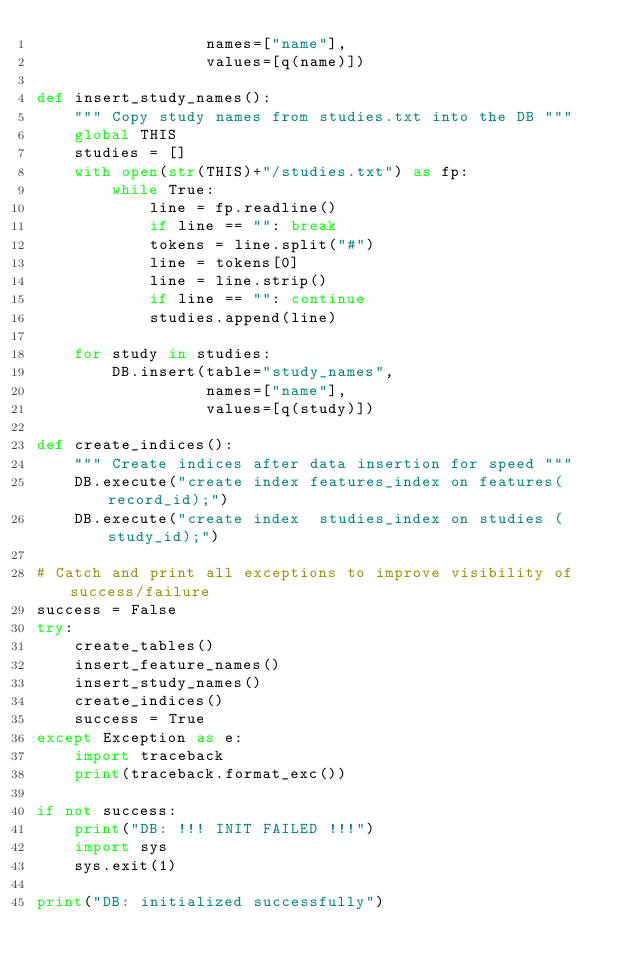Convert code to text. <code><loc_0><loc_0><loc_500><loc_500><_Python_>                  names=["name"],
                  values=[q(name)])

def insert_study_names():
    """ Copy study names from studies.txt into the DB """
    global THIS
    studies = []
    with open(str(THIS)+"/studies.txt") as fp:
        while True:
            line = fp.readline()
            if line == "": break
            tokens = line.split("#")
            line = tokens[0]
            line = line.strip()
            if line == "": continue
            studies.append(line)

    for study in studies:
        DB.insert(table="study_names",
                  names=["name"],
                  values=[q(study)])

def create_indices():
    """ Create indices after data insertion for speed """
    DB.execute("create index features_index on features(record_id);")
    DB.execute("create index  studies_index on studies ( study_id);")

# Catch and print all exceptions to improve visibility of success/failure
success = False
try:
    create_tables()
    insert_feature_names()
    insert_study_names()
    create_indices()
    success = True
except Exception as e:
    import traceback
    print(traceback.format_exc())

if not success:
    print("DB: !!! INIT FAILED !!!")
    import sys
    sys.exit(1)

print("DB: initialized successfully")
</code> 